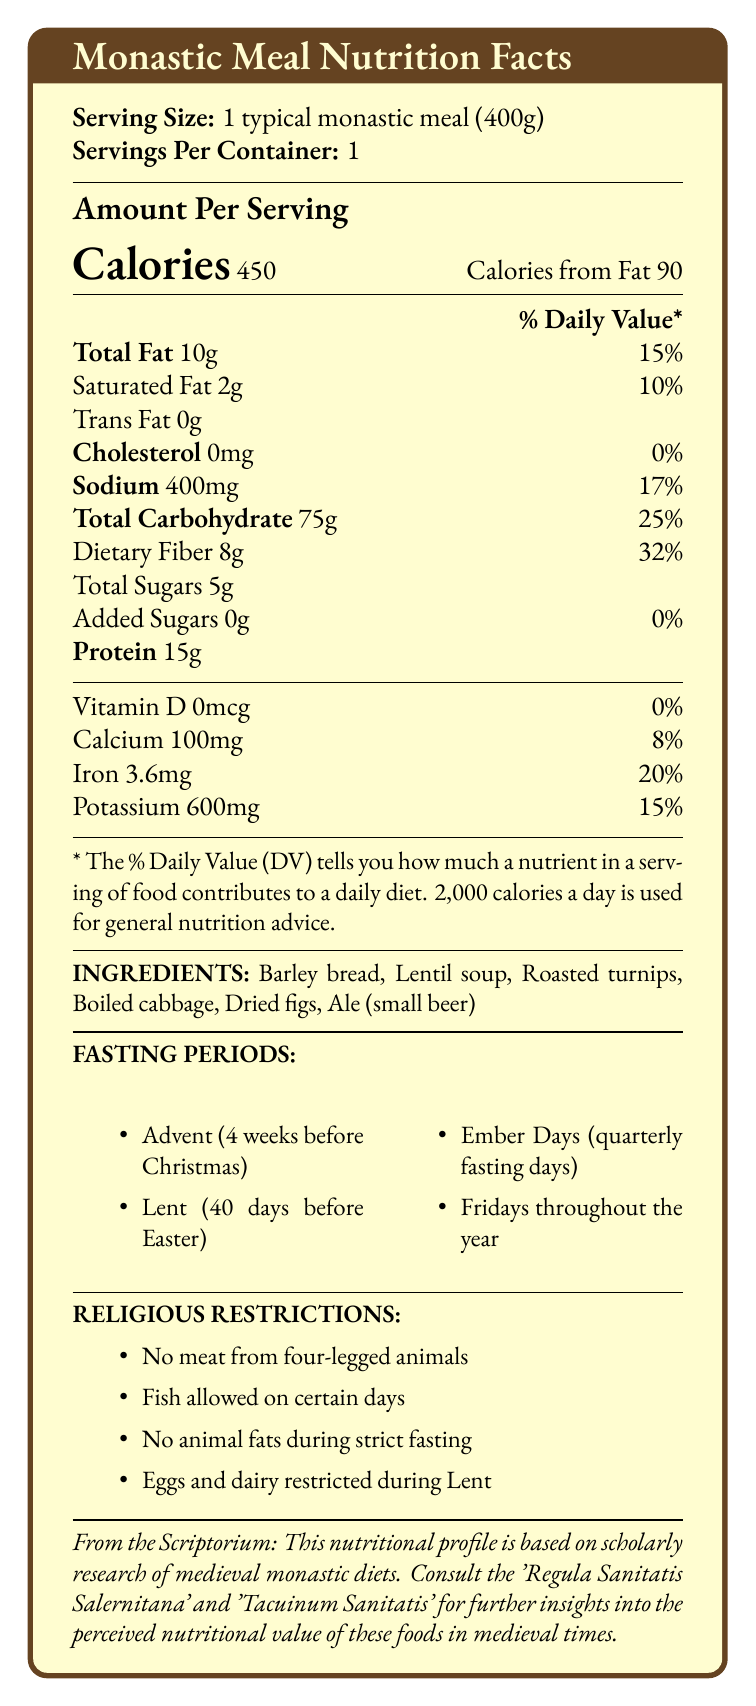what is the serving size? The document lists the serving size as "1 typical monastic meal (400g)."
Answer: 1 typical monastic meal (400g) how many calories does one typical monastic meal contain? Under the "Amount Per Serving" section, it states "Calories 450."
Answer: 450 calories how much protein is in one serving of the meal? The document states that the meal contains 15g of protein in the macronutrient section.
Answer: 15g which fasting periods are mentioned in the document? The document lists four fasting periods under "FASTING PERIODS".
Answer: Advent, Lent, Ember Days, Fridays throughout the year what are the main ingredients of the typical monastic meal? The "INGREDIENTS" section lists these six items.
Answer: Barley bread, Lentil soup, Roasted turnips, Boiled cabbage, Dried figs, Ale (small beer) which of the following restrictions applies during Lent? A. Fish is restricted B. Eggs and dairy products are restricted C. All animal products are allowed D. All vegetables are restricted The "RELIGIOUS RESTRICTIONS" section mentions that eggs and dairy products are restricted during Lent.
Answer: B what is the percentage daily value of dietary fiber in the meal? The "Macronutrients" section lists dietary fiber as 8g and 32% of the daily value.
Answer: 32% does this monastic meal contain any cholesterol? The document indicates that the meal contains 0mg of cholesterol.
Answer: No how often were monks allowed two meals per day, except during fasting periods? The "scholarlyNotes" section mentions that according to the Rule of Saint Benedict, monks were allowed two meals per day except during fasting periods.
Answer: According to the Rule of Saint Benedict which micronutrient is absent in this meal? A. Vitamin D B. Calcium C. Iron D. Potassium The document states there is 0mcg of Vitamin D in the micronutrients section.
Answer: A does the meal contain any added sugars? The document mentions that the meal has 0g of added sugars.
Answer: No summarize the main idea of the document. The document gives a detailed breakdown of the nutritional values and dietary context of a typical meal consumed by medieval monks, including specific fasting periods and dietary restrictions based on religious practices.
Answer: The document provides a nutritional profile of a typical monastic meal, including its serving size, calorie content, macronutrient and micronutrient information, ingredients, and religious fasting and dietary restrictions. how much sodium does one serving of this meal contain? The "Macronutrients" section lists sodium as 400mg.
Answer: 400mg how many total carbohydrates are in one serving of the meal? The document states that there are 75g of total carbohydrates in one serving under the macronutrient section.
Answer: 75g which medieval health handbooks are mentioned in the scholarly notes? The "scholarlyNotes" section specifically mentions these two handbooks.
Answer: 'Regula Sanitatis Salernitana' and 'Tacuinum Sanitatis' what is the percentage daily value of iron in the meal? The "Micronutrients" section lists iron as 3.6mg and 20% of the daily value.
Answer: 20% which nutrients have no daily value provided? These nutrients are listed without a daily value percentage in the document.
Answer: Trans Fat, Total Sugars, Vitamin D what are typical foods included in a monastic diet? The "typicalFoods" section lists these items.
Answer: Whole grain breads, Legumes, Root vegetables, Leafy greens, Fruits, Fish, Nuts and seeds, Herbs and spices how does the meal comply with the rule of no meat from four-legged animals? The ingredient list shows that the meal does not contain any meat from four-legged animals, complying with the religious restriction.
Answer: It includes barley bread, lentil soup, roasted turnips, boiled cabbage, dried figs, and ale, none of which are meat from four-legged animals. what influence does 'Regula Sanitatis Salernitana' have on the dietary guidelines? The document mentions the 'Regula Sanitatis Salernitana' provides dietary guidelines influenced by monastic practices but does not elaborate on the specifics of this influence.
Answer: Cannot be determined 